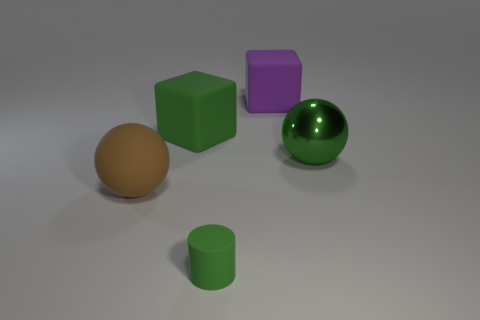Is the small matte thing the same color as the big metallic thing?
Your answer should be compact. Yes. Are there any other things that are made of the same material as the large green ball?
Give a very brief answer. No. Do the big rubber sphere and the rubber object that is in front of the large brown matte sphere have the same color?
Give a very brief answer. No. What is the color of the large ball that is on the right side of the big brown matte sphere behind the green thing that is in front of the metallic ball?
Your answer should be very brief. Green. Is there another thing of the same shape as the large brown rubber thing?
Offer a very short reply. Yes. What is the color of the block that is the same size as the purple object?
Keep it short and to the point. Green. What material is the large sphere that is behind the big brown thing?
Offer a terse response. Metal. There is a big green rubber object to the left of the purple matte block; is its shape the same as the big purple rubber object right of the matte sphere?
Keep it short and to the point. Yes. Are there the same number of small cylinders behind the green shiny ball and small gray matte things?
Keep it short and to the point. Yes. What number of small green cylinders have the same material as the green sphere?
Ensure brevity in your answer.  0. 